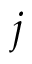Convert formula to latex. <formula><loc_0><loc_0><loc_500><loc_500>j</formula> 